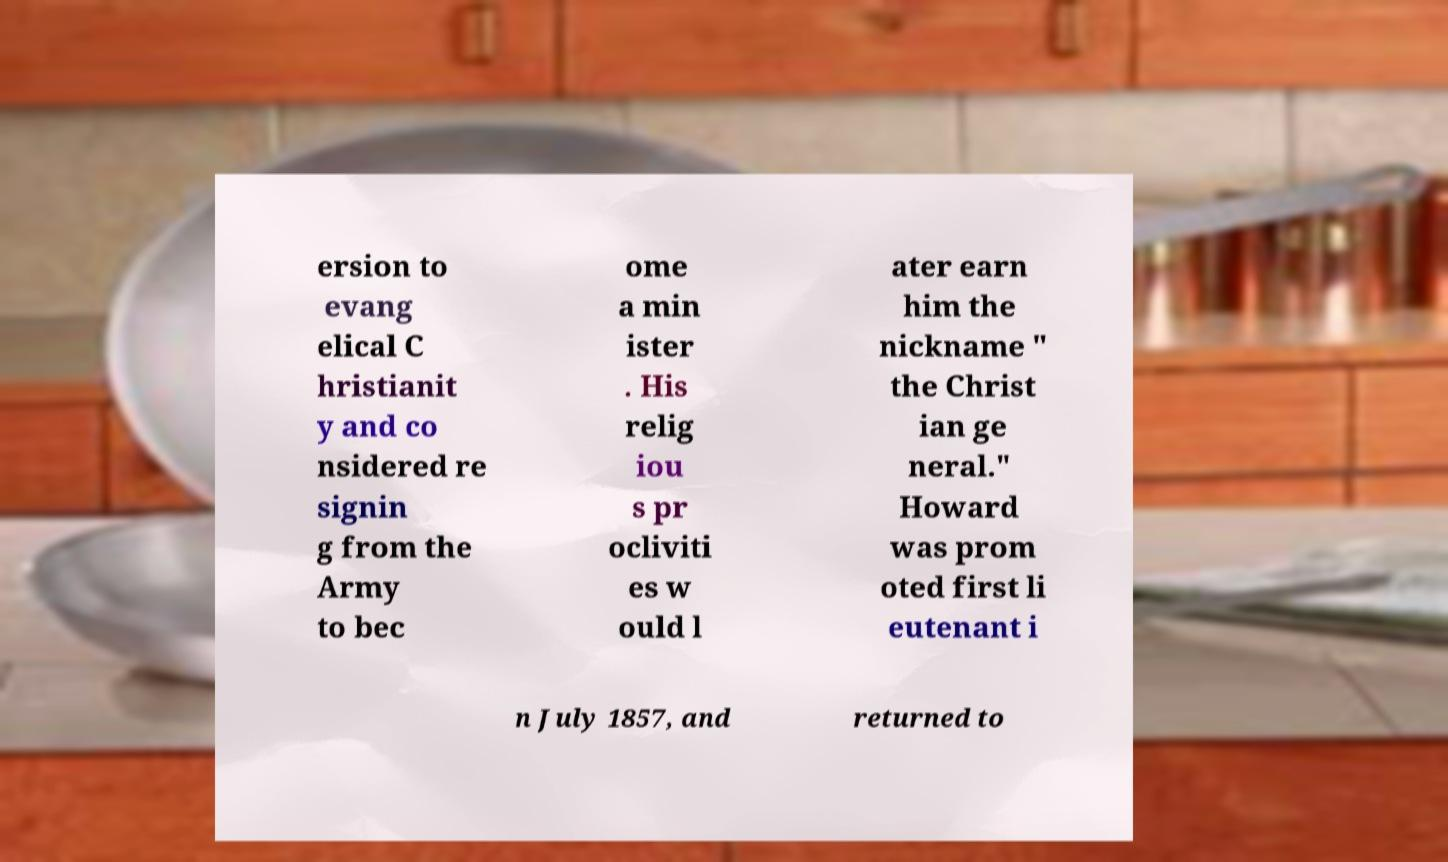I need the written content from this picture converted into text. Can you do that? ersion to evang elical C hristianit y and co nsidered re signin g from the Army to bec ome a min ister . His relig iou s pr ocliviti es w ould l ater earn him the nickname " the Christ ian ge neral." Howard was prom oted first li eutenant i n July 1857, and returned to 